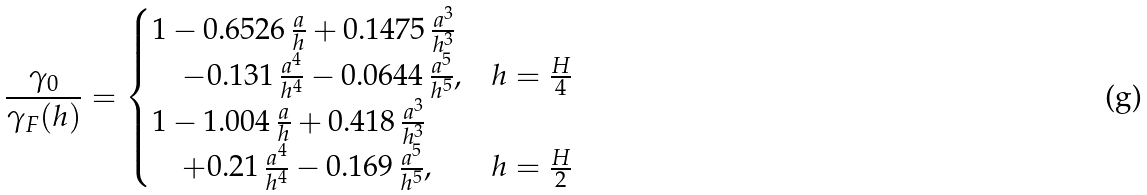<formula> <loc_0><loc_0><loc_500><loc_500>\frac { \gamma _ { 0 } } { \gamma _ { F } ( h ) } = \begin{cases} 1 - 0 . 6 5 2 6 \, \frac { a } { h } + 0 . 1 4 7 5 \, \frac { a ^ { 3 } } { h ^ { 3 } } \\ \quad - 0 . 1 3 1 \, \frac { a ^ { 4 } } { h ^ { 4 } } - 0 . 0 6 4 4 \, \frac { a ^ { 5 } } { h ^ { 5 } } , & h = \frac { H } { 4 } \\ 1 - 1 . 0 0 4 \, \frac { a } { h } + 0 . 4 1 8 \, \frac { a ^ { 3 } } { h ^ { 3 } } \\ \quad + 0 . 2 1 \, \frac { a ^ { 4 } } { h ^ { 4 } } - 0 . 1 6 9 \, \frac { a ^ { 5 } } { h ^ { 5 } } , & h = \frac { H } { 2 } \end{cases}</formula> 